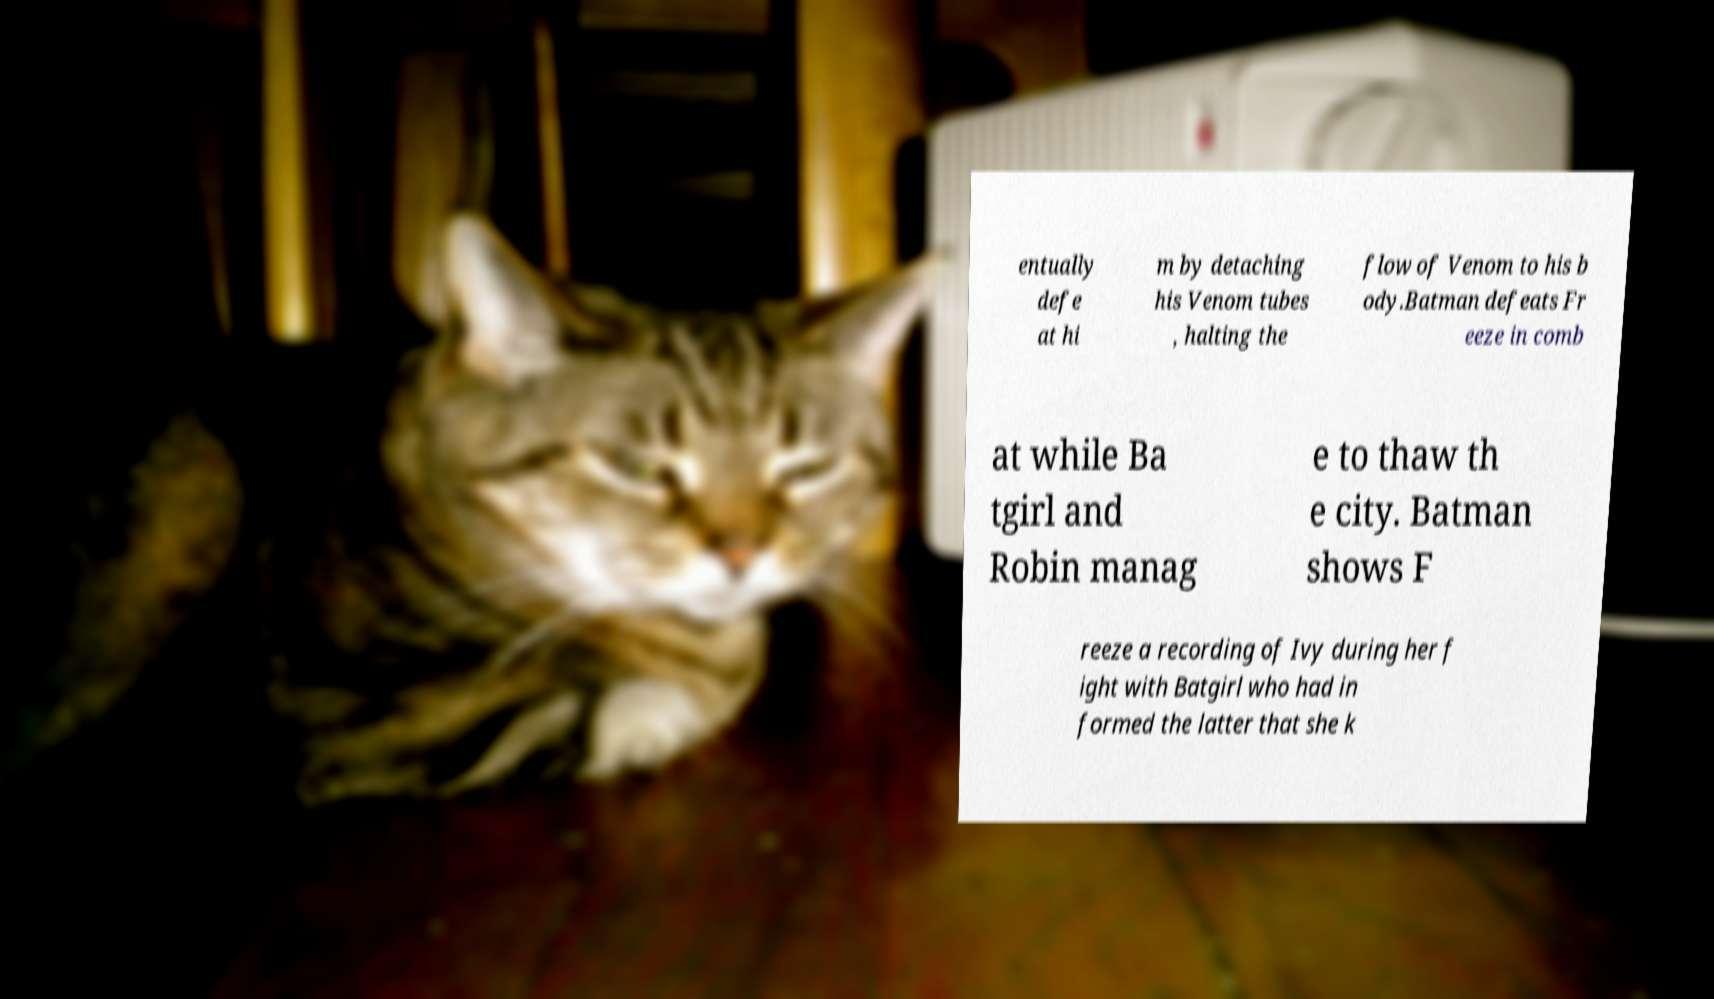Can you accurately transcribe the text from the provided image for me? entually defe at hi m by detaching his Venom tubes , halting the flow of Venom to his b ody.Batman defeats Fr eeze in comb at while Ba tgirl and Robin manag e to thaw th e city. Batman shows F reeze a recording of Ivy during her f ight with Batgirl who had in formed the latter that she k 